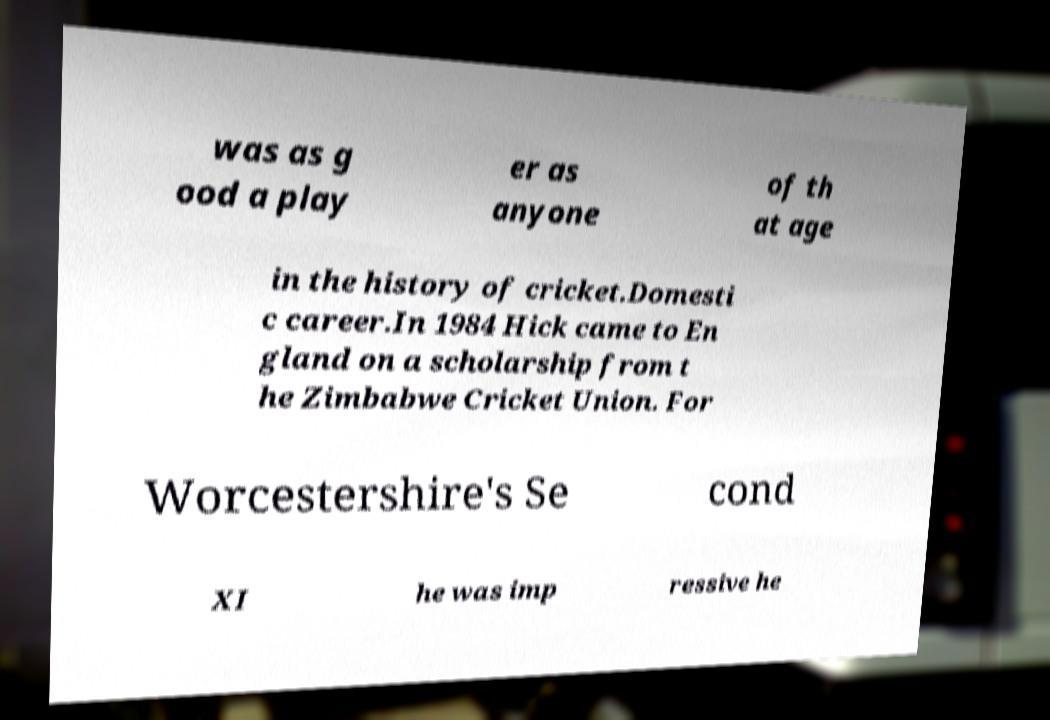Could you extract and type out the text from this image? was as g ood a play er as anyone of th at age in the history of cricket.Domesti c career.In 1984 Hick came to En gland on a scholarship from t he Zimbabwe Cricket Union. For Worcestershire's Se cond XI he was imp ressive he 